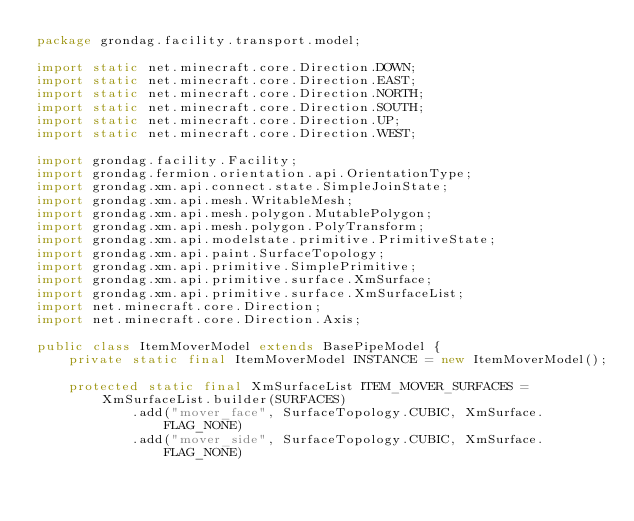Convert code to text. <code><loc_0><loc_0><loc_500><loc_500><_Java_>package grondag.facility.transport.model;

import static net.minecraft.core.Direction.DOWN;
import static net.minecraft.core.Direction.EAST;
import static net.minecraft.core.Direction.NORTH;
import static net.minecraft.core.Direction.SOUTH;
import static net.minecraft.core.Direction.UP;
import static net.minecraft.core.Direction.WEST;

import grondag.facility.Facility;
import grondag.fermion.orientation.api.OrientationType;
import grondag.xm.api.connect.state.SimpleJoinState;
import grondag.xm.api.mesh.WritableMesh;
import grondag.xm.api.mesh.polygon.MutablePolygon;
import grondag.xm.api.mesh.polygon.PolyTransform;
import grondag.xm.api.modelstate.primitive.PrimitiveState;
import grondag.xm.api.paint.SurfaceTopology;
import grondag.xm.api.primitive.SimplePrimitive;
import grondag.xm.api.primitive.surface.XmSurface;
import grondag.xm.api.primitive.surface.XmSurfaceList;
import net.minecraft.core.Direction;
import net.minecraft.core.Direction.Axis;

public class ItemMoverModel extends BasePipeModel {
	private static final ItemMoverModel INSTANCE = new ItemMoverModel();

	protected static final XmSurfaceList ITEM_MOVER_SURFACES = XmSurfaceList.builder(SURFACES)
			.add("mover_face", SurfaceTopology.CUBIC, XmSurface.FLAG_NONE)
			.add("mover_side", SurfaceTopology.CUBIC, XmSurface.FLAG_NONE)</code> 